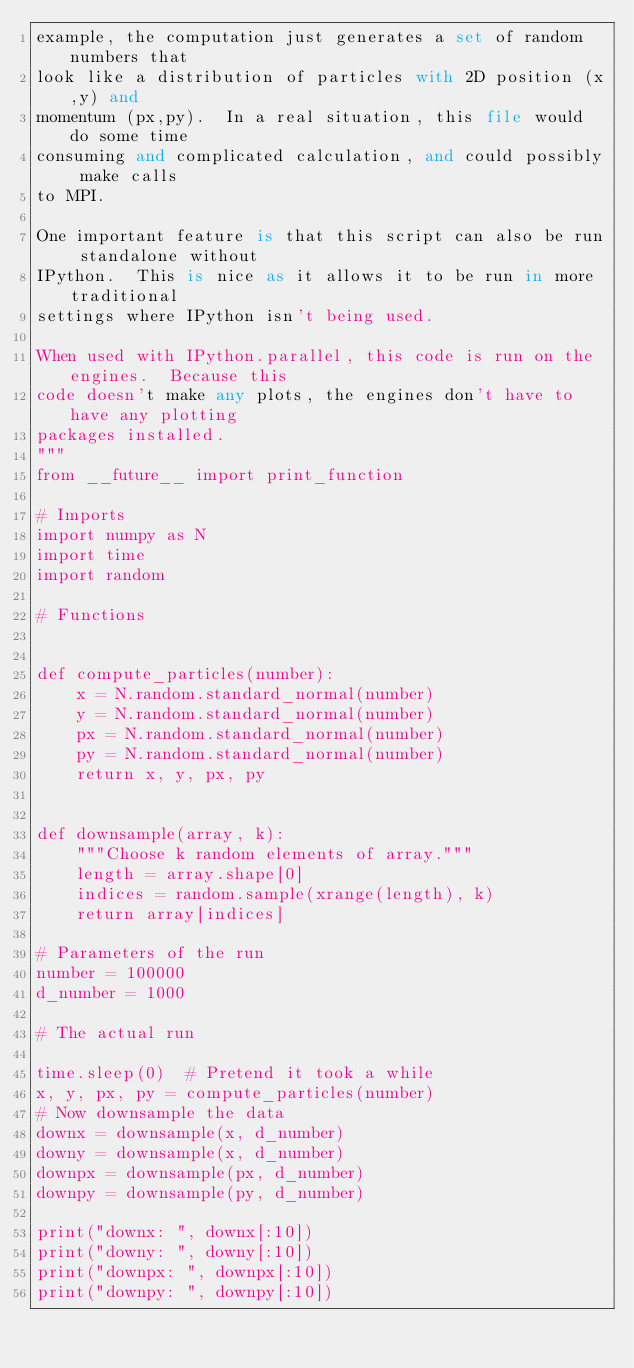<code> <loc_0><loc_0><loc_500><loc_500><_Python_>example, the computation just generates a set of random numbers that
look like a distribution of particles with 2D position (x,y) and
momentum (px,py).  In a real situation, this file would do some time
consuming and complicated calculation, and could possibly make calls
to MPI.

One important feature is that this script can also be run standalone without
IPython.  This is nice as it allows it to be run in more traditional
settings where IPython isn't being used.

When used with IPython.parallel, this code is run on the engines.  Because this
code doesn't make any plots, the engines don't have to have any plotting
packages installed.
"""
from __future__ import print_function

# Imports
import numpy as N
import time
import random

# Functions


def compute_particles(number):
    x = N.random.standard_normal(number)
    y = N.random.standard_normal(number)
    px = N.random.standard_normal(number)
    py = N.random.standard_normal(number)
    return x, y, px, py


def downsample(array, k):
    """Choose k random elements of array."""
    length = array.shape[0]
    indices = random.sample(xrange(length), k)
    return array[indices]

# Parameters of the run
number = 100000
d_number = 1000

# The actual run

time.sleep(0)  # Pretend it took a while
x, y, px, py = compute_particles(number)
# Now downsample the data
downx = downsample(x, d_number)
downy = downsample(x, d_number)
downpx = downsample(px, d_number)
downpy = downsample(py, d_number)

print("downx: ", downx[:10])
print("downy: ", downy[:10])
print("downpx: ", downpx[:10])
print("downpy: ", downpy[:10])
</code> 